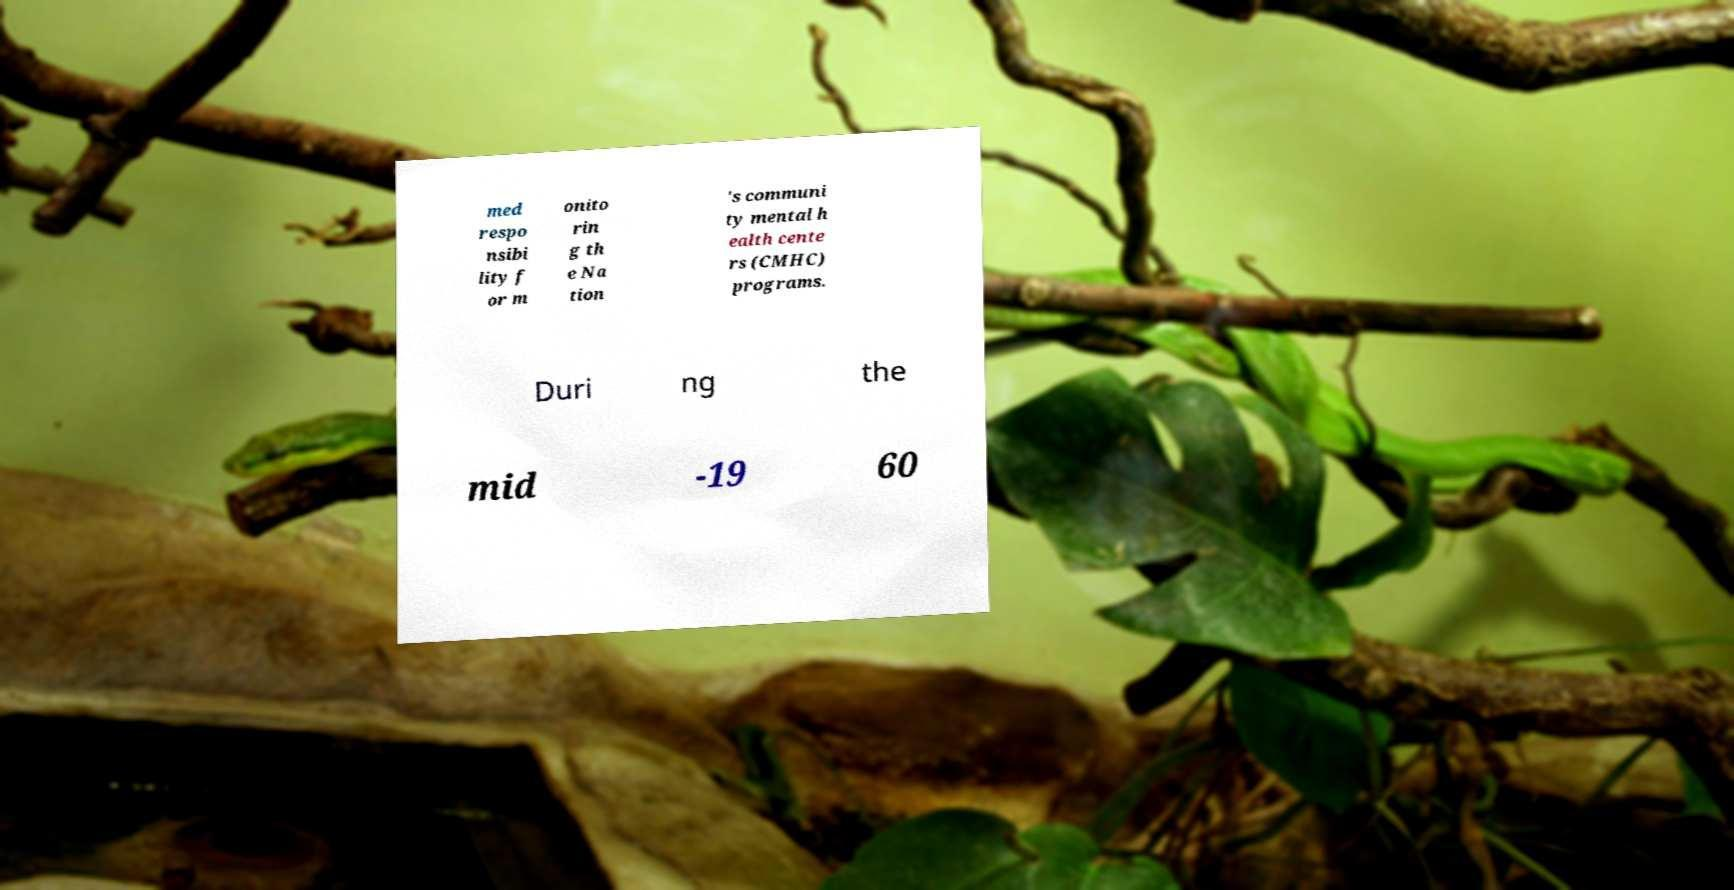There's text embedded in this image that I need extracted. Can you transcribe it verbatim? med respo nsibi lity f or m onito rin g th e Na tion 's communi ty mental h ealth cente rs (CMHC) programs. Duri ng the mid -19 60 